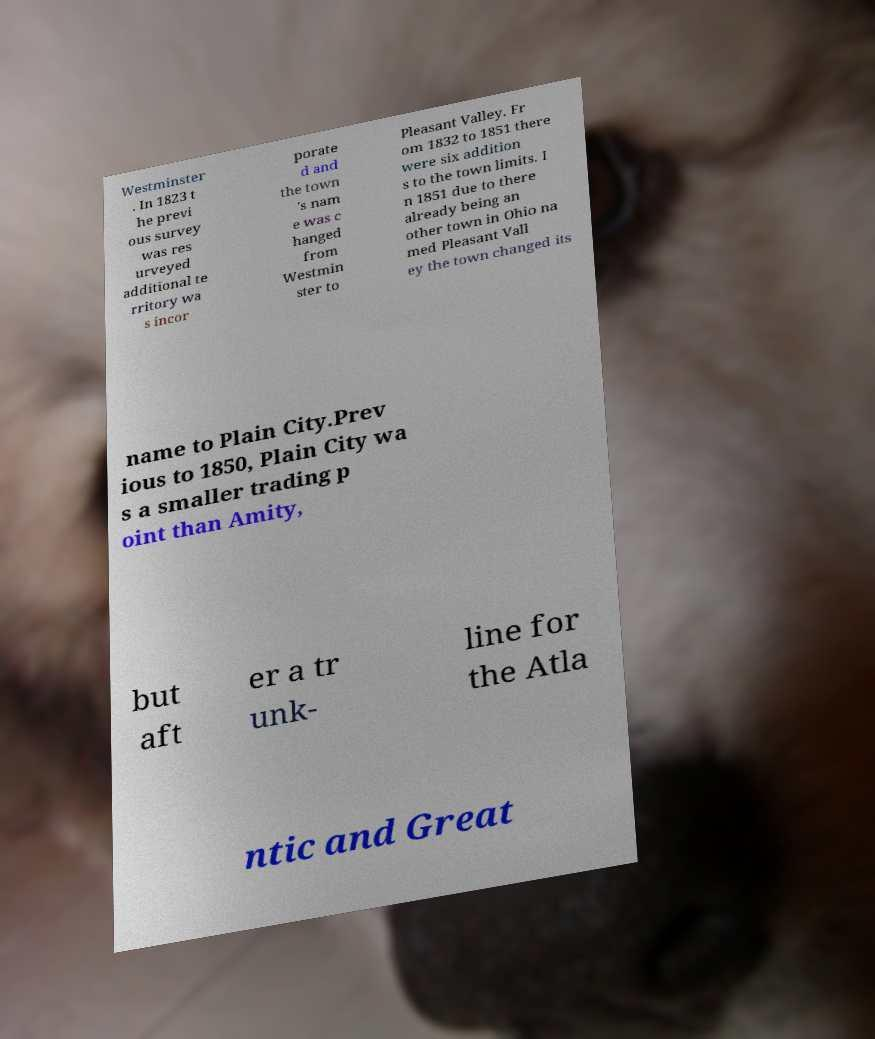Please read and relay the text visible in this image. What does it say? Westminster . In 1823 t he previ ous survey was res urveyed additional te rritory wa s incor porate d and the town 's nam e was c hanged from Westmin ster to Pleasant Valley. Fr om 1832 to 1851 there were six addition s to the town limits. I n 1851 due to there already being an other town in Ohio na med Pleasant Vall ey the town changed its name to Plain City.Prev ious to 1850, Plain City wa s a smaller trading p oint than Amity, but aft er a tr unk- line for the Atla ntic and Great 